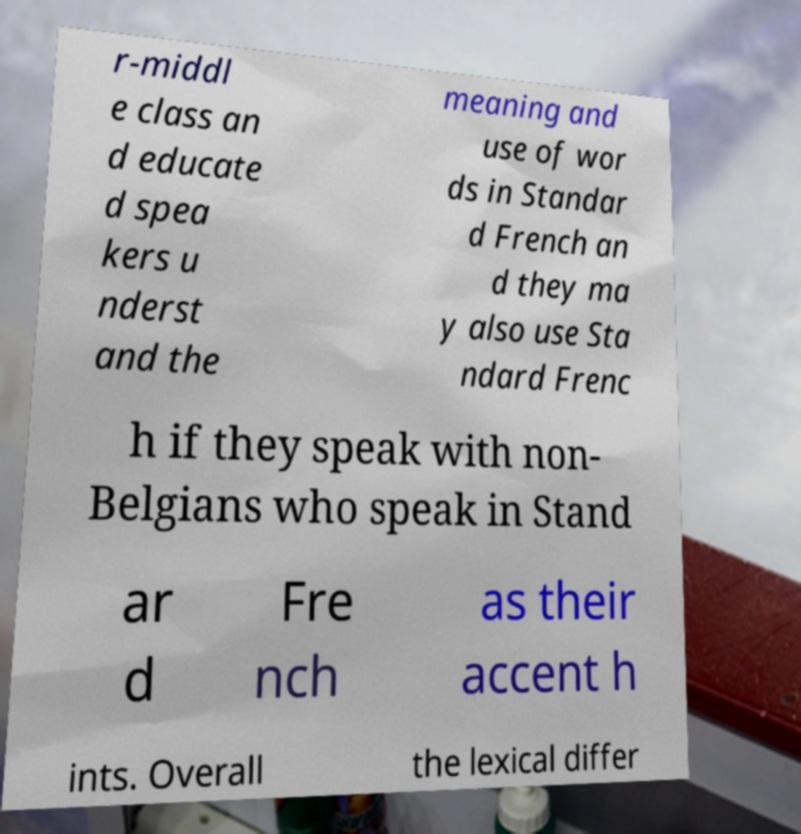Can you read and provide the text displayed in the image?This photo seems to have some interesting text. Can you extract and type it out for me? r-middl e class an d educate d spea kers u nderst and the meaning and use of wor ds in Standar d French an d they ma y also use Sta ndard Frenc h if they speak with non- Belgians who speak in Stand ar d Fre nch as their accent h ints. Overall the lexical differ 